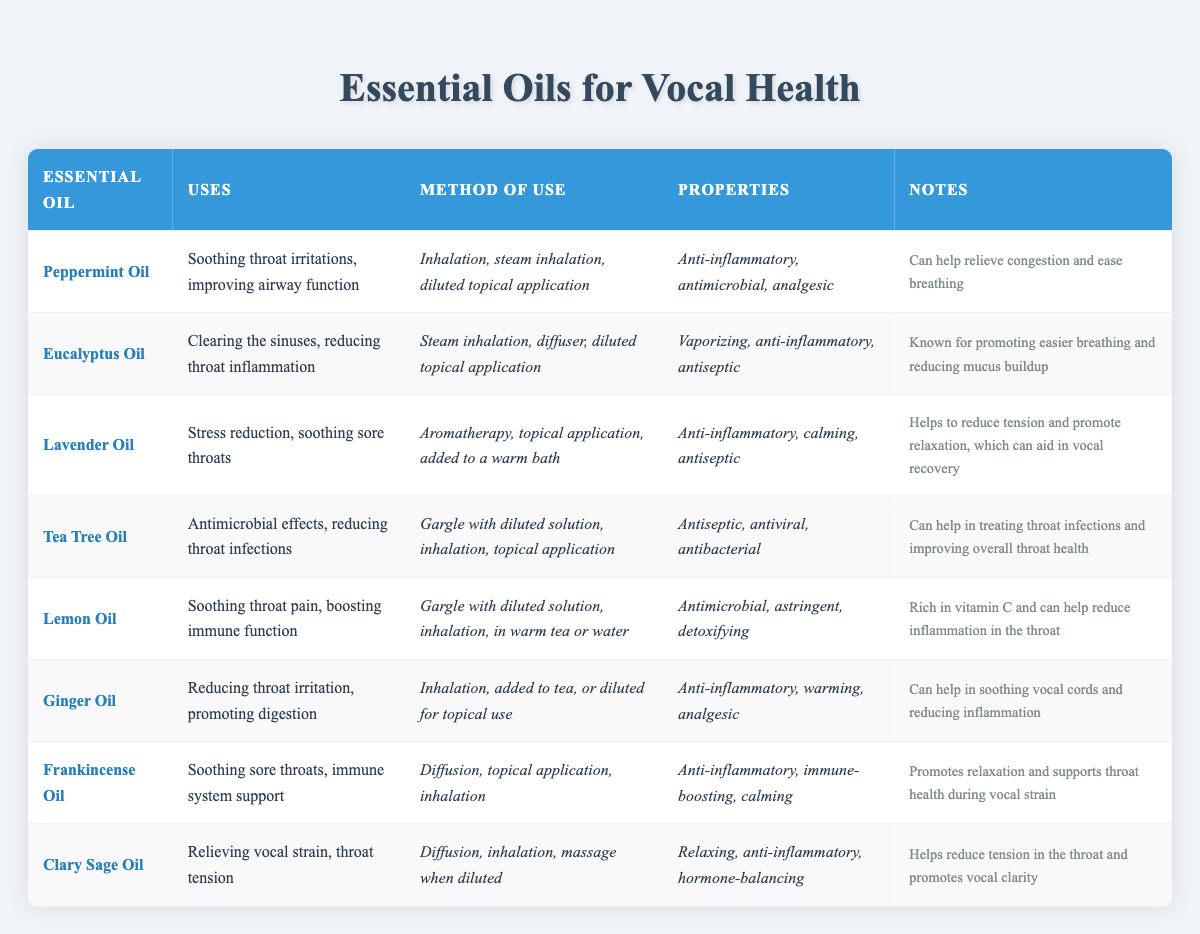What essential oil is known for soothing throat irritations? According to the table, "Peppermint Oil" is listed under "Uses" for soothing throat irritations.
Answer: Peppermint Oil Which oils can be used for steam inhalation? The oils that can be used for steam inhalation include "Peppermint Oil," "Eucalyptus Oil," "Tea Tree Oil," "Ginger Oil," "Frankincense Oil," and "Clary Sage Oil." The "Method of Use" mentions steam inhalation for these oils.
Answer: Peppermint Oil, Eucalyptus Oil, Tea Tree Oil, Ginger Oil, Frankincense Oil, Clary Sage Oil True or False: Lavender Oil is used for promoting digestion. The table states that "Lavender Oil" is used for stress reduction and soothing sore throats, but it does not mention anything about promoting digestion. Therefore, the statement is false.
Answer: False What are the properties of Tea Tree Oil? The table outlines that the properties of "Tea Tree Oil" include being antiseptic, antiviral, and antibacterial.
Answer: Antiseptic, antiviral, antibacterial If I need to relieve vocal strain, which oils would be beneficial? The table indicates "Clary Sage Oil" is particularly noted for relieving vocal strain, alongside "Lavender Oil" which is used for soothing sore throats. Both support vocal health, with Clary Sage Oil focusing explicitly on tension relief.
Answer: Clary Sage Oil, Lavender Oil Which essential oil is rich in vitamin C? The table mentions "Lemon Oil" as being rich in vitamin C and its use in soothing throat pain and boosting immune function.
Answer: Lemon Oil How many essential oils listed have anti-inflammatory properties? From the table, the essential oils with anti-inflammatory properties are "Peppermint Oil," "Eucalyptus Oil," "Lavender Oil," "Ginger Oil," "Frankincense Oil," and "Clary Sage Oil." Summing these gives us a total of six oils.
Answer: Six oils What method of use is common for soothing sore throats? The common methods of use for soothing sore throats according to the table include "Aromatherapy," "topical application," and "gargle with a diluted solution," which are mentioned for several oils like "Lavender Oil" and "Tea Tree Oil."
Answer: Aromatherapy, topical application, gargle with diluted solution 